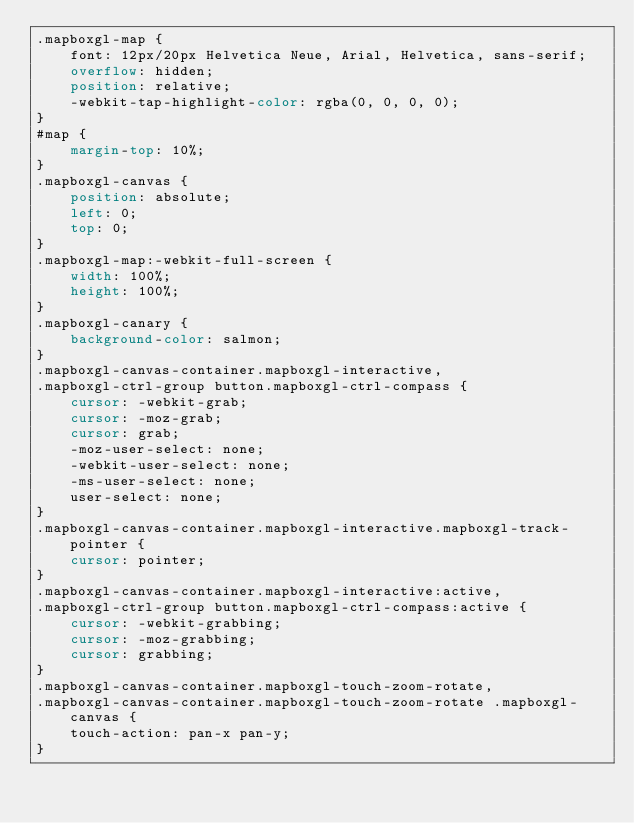<code> <loc_0><loc_0><loc_500><loc_500><_CSS_>.mapboxgl-map {
    font: 12px/20px Helvetica Neue, Arial, Helvetica, sans-serif;
    overflow: hidden;
    position: relative;
    -webkit-tap-highlight-color: rgba(0, 0, 0, 0);
}
#map {
    margin-top: 10%;
}
.mapboxgl-canvas {
    position: absolute;
    left: 0;
    top: 0;
}
.mapboxgl-map:-webkit-full-screen {
    width: 100%;
    height: 100%;
}
.mapboxgl-canary {
    background-color: salmon;
}
.mapboxgl-canvas-container.mapboxgl-interactive,
.mapboxgl-ctrl-group button.mapboxgl-ctrl-compass {
    cursor: -webkit-grab;
    cursor: -moz-grab;
    cursor: grab;
    -moz-user-select: none;
    -webkit-user-select: none;
    -ms-user-select: none;
    user-select: none;
}
.mapboxgl-canvas-container.mapboxgl-interactive.mapboxgl-track-pointer {
    cursor: pointer;
}
.mapboxgl-canvas-container.mapboxgl-interactive:active,
.mapboxgl-ctrl-group button.mapboxgl-ctrl-compass:active {
    cursor: -webkit-grabbing;
    cursor: -moz-grabbing;
    cursor: grabbing;
}
.mapboxgl-canvas-container.mapboxgl-touch-zoom-rotate,
.mapboxgl-canvas-container.mapboxgl-touch-zoom-rotate .mapboxgl-canvas {
    touch-action: pan-x pan-y;
}</code> 